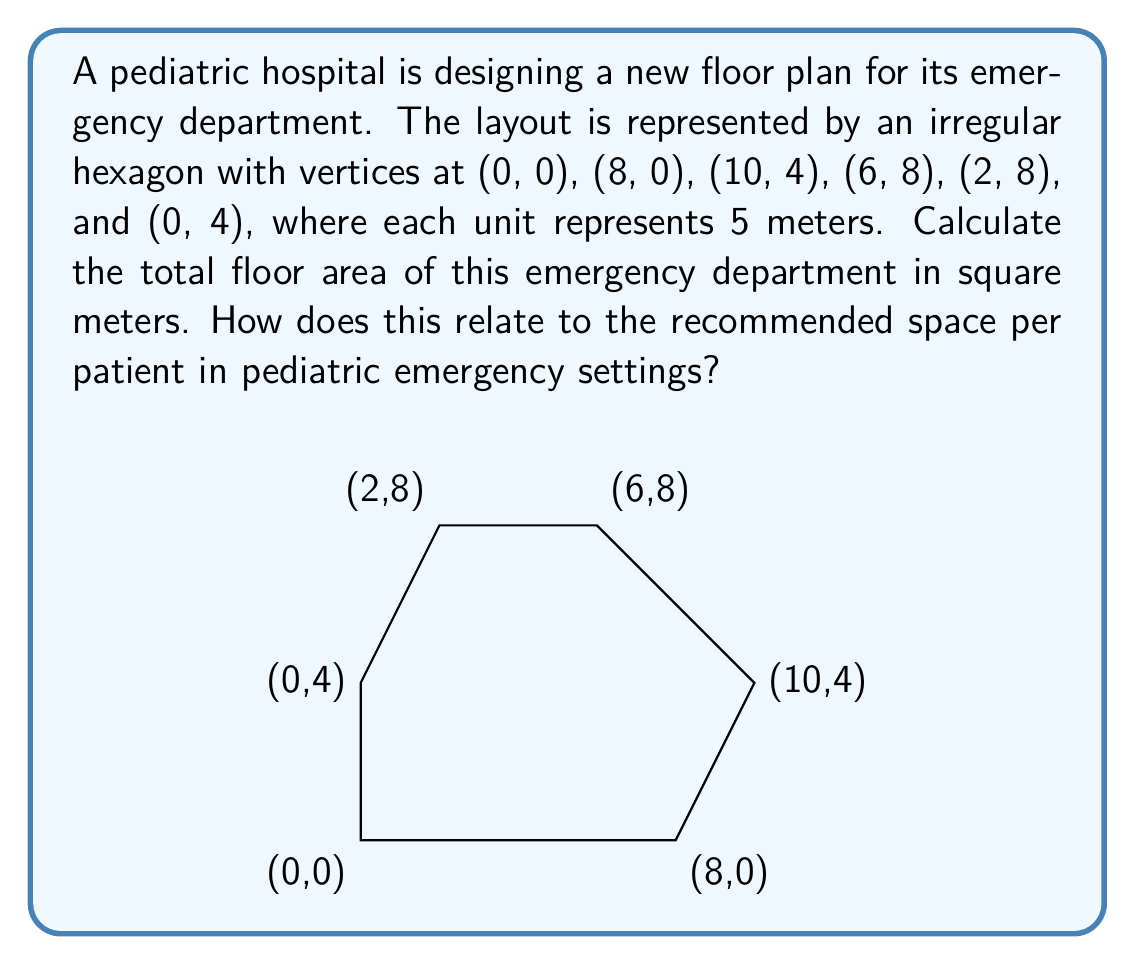Give your solution to this math problem. To solve this problem, we'll use the following steps:

1) First, we'll calculate the area of the hexagon using the shoelace formula (also known as the surveyor's formula). This formula calculates the area of a polygon given its vertices.

2) The shoelace formula for a polygon with vertices $(x_1, y_1), (x_2, y_2), ..., (x_n, y_n)$ is:

   $$A = \frac{1}{2}|(x_1y_2 + x_2y_3 + ... + x_ny_1) - (y_1x_2 + y_2x_3 + ... + y_nx_1)|$$

3) Applying this to our hexagon:

   $$A = \frac{1}{2}|(0\cdot0 + 8\cdot4 + 10\cdot8 + 6\cdot8 + 2\cdot4 + 0\cdot0) - (0\cdot8 + 0\cdot10 + 4\cdot6 + 8\cdot2 + 8\cdot0 + 4\cdot0)|$$

4) Simplifying:

   $$A = \frac{1}{2}|(32 + 80 + 48 + 8) - (24 + 16)|$$
   $$A = \frac{1}{2}|168 - 40|$$
   $$A = \frac{1}{2}(128) = 64$$

5) This gives us the area in square units. Remember that each unit represents 5 meters, so we need to multiply our result by $5^2 = 25$ to get the area in square meters:

   $$64 \cdot 25 = 1600 \text{ square meters}$$

6) Regarding the relevance to pediatric emergency settings: The recommended space per patient in pediatric emergency departments typically ranges from 15 to 25 square meters, depending on the level of care provided. With a total area of 1600 square meters, this emergency department could potentially accommodate between 64 to 106 patients, assuming all space is used for patient care (which is not realistic as some space would be needed for staff areas, equipment storage, etc.).
Answer: The total floor area of the emergency department is 1600 square meters. 